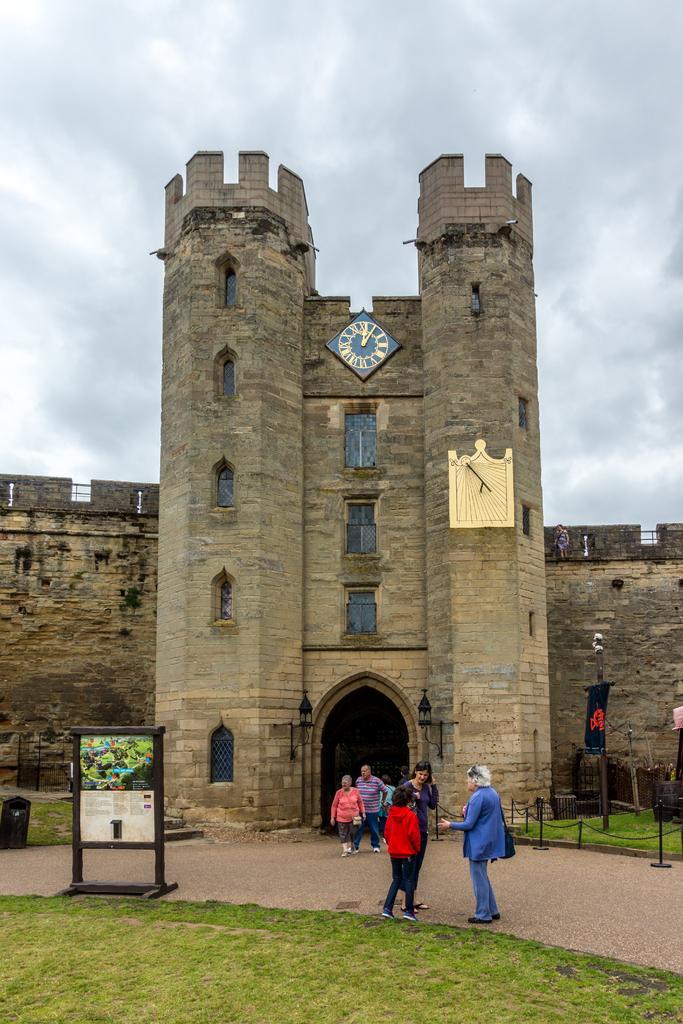How would you summarize this image in a sentence or two? In the picture I can see building, in front we can see few people, board and grass. 